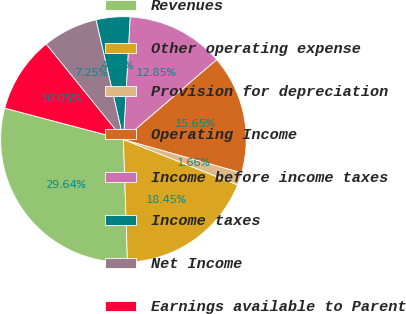Convert chart. <chart><loc_0><loc_0><loc_500><loc_500><pie_chart><fcel>Revenues<fcel>Other operating expense<fcel>Provision for depreciation<fcel>Operating Income<fcel>Income before income taxes<fcel>Income taxes<fcel>Net Income<fcel>Earnings available to Parent<nl><fcel>29.64%<fcel>18.45%<fcel>1.66%<fcel>15.65%<fcel>12.85%<fcel>4.46%<fcel>7.25%<fcel>10.05%<nl></chart> 